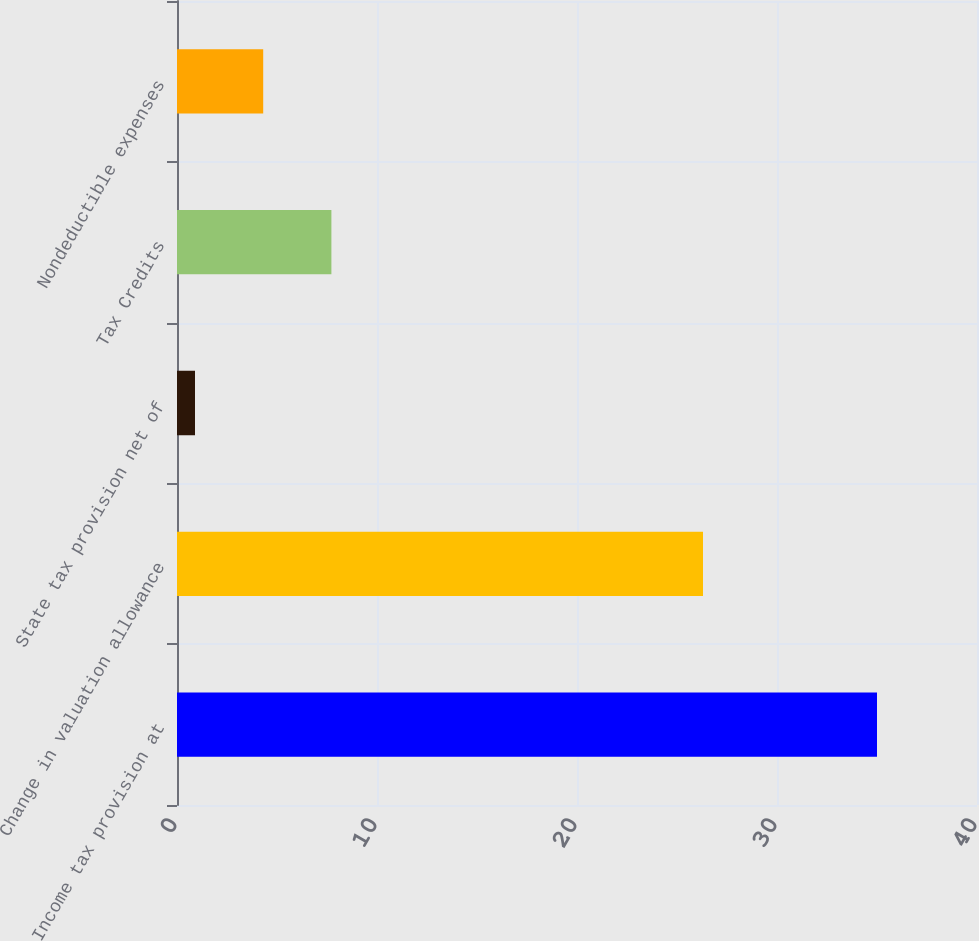Convert chart. <chart><loc_0><loc_0><loc_500><loc_500><bar_chart><fcel>Income tax provision at<fcel>Change in valuation allowance<fcel>State tax provision net of<fcel>Tax Credits<fcel>Nondeductible expenses<nl><fcel>35<fcel>26.3<fcel>0.9<fcel>7.72<fcel>4.31<nl></chart> 